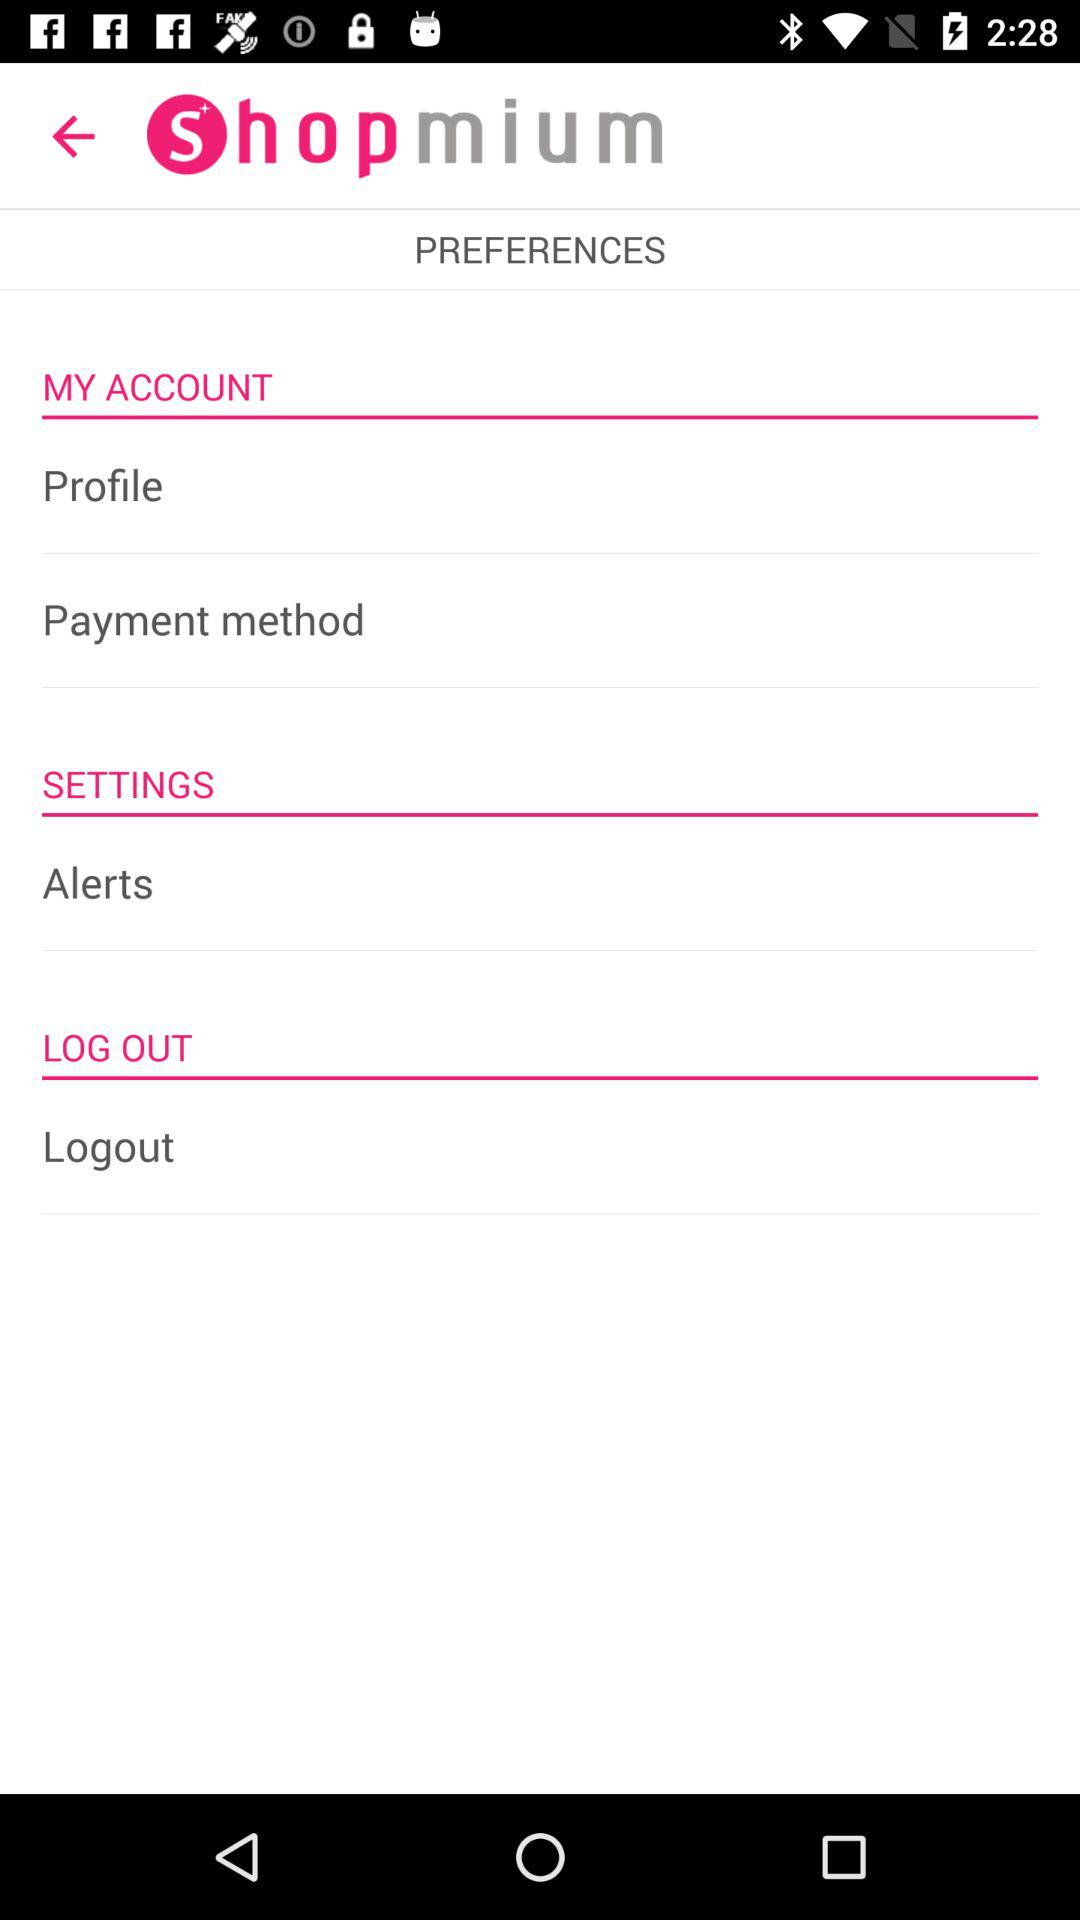What is the name of the application? The name of the application is "Shopmium". 